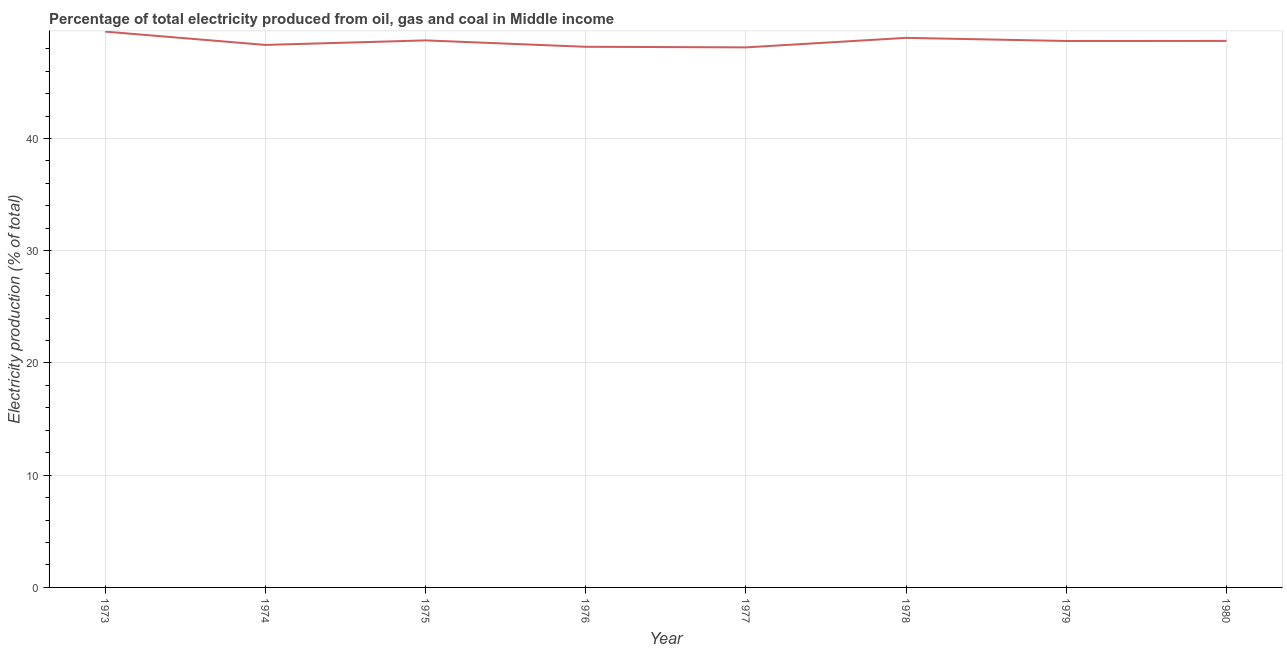What is the electricity production in 1979?
Ensure brevity in your answer.  48.7. Across all years, what is the maximum electricity production?
Your answer should be compact. 49.53. Across all years, what is the minimum electricity production?
Offer a terse response. 48.12. In which year was the electricity production minimum?
Provide a succinct answer. 1977. What is the sum of the electricity production?
Provide a succinct answer. 389.29. What is the difference between the electricity production in 1973 and 1974?
Provide a succinct answer. 1.19. What is the average electricity production per year?
Your answer should be very brief. 48.66. What is the median electricity production?
Provide a succinct answer. 48.7. Do a majority of the years between 1974 and 1976 (inclusive) have electricity production greater than 24 %?
Your answer should be very brief. Yes. What is the ratio of the electricity production in 1973 to that in 1975?
Offer a very short reply. 1.02. Is the electricity production in 1973 less than that in 1978?
Ensure brevity in your answer.  No. Is the difference between the electricity production in 1977 and 1978 greater than the difference between any two years?
Keep it short and to the point. No. What is the difference between the highest and the second highest electricity production?
Your answer should be very brief. 0.56. What is the difference between the highest and the lowest electricity production?
Your response must be concise. 1.41. In how many years, is the electricity production greater than the average electricity production taken over all years?
Keep it short and to the point. 5. Does the electricity production monotonically increase over the years?
Provide a succinct answer. No. What is the difference between two consecutive major ticks on the Y-axis?
Your answer should be compact. 10. Are the values on the major ticks of Y-axis written in scientific E-notation?
Make the answer very short. No. What is the title of the graph?
Your answer should be very brief. Percentage of total electricity produced from oil, gas and coal in Middle income. What is the label or title of the X-axis?
Your answer should be very brief. Year. What is the label or title of the Y-axis?
Offer a very short reply. Electricity production (% of total). What is the Electricity production (% of total) of 1973?
Make the answer very short. 49.53. What is the Electricity production (% of total) of 1974?
Give a very brief answer. 48.34. What is the Electricity production (% of total) in 1975?
Your answer should be compact. 48.75. What is the Electricity production (% of total) in 1976?
Offer a terse response. 48.18. What is the Electricity production (% of total) in 1977?
Your answer should be compact. 48.12. What is the Electricity production (% of total) of 1978?
Keep it short and to the point. 48.97. What is the Electricity production (% of total) of 1979?
Ensure brevity in your answer.  48.7. What is the Electricity production (% of total) in 1980?
Provide a short and direct response. 48.7. What is the difference between the Electricity production (% of total) in 1973 and 1974?
Offer a terse response. 1.19. What is the difference between the Electricity production (% of total) in 1973 and 1975?
Your answer should be compact. 0.78. What is the difference between the Electricity production (% of total) in 1973 and 1976?
Provide a short and direct response. 1.35. What is the difference between the Electricity production (% of total) in 1973 and 1977?
Your response must be concise. 1.41. What is the difference between the Electricity production (% of total) in 1973 and 1978?
Your response must be concise. 0.56. What is the difference between the Electricity production (% of total) in 1973 and 1979?
Provide a short and direct response. 0.83. What is the difference between the Electricity production (% of total) in 1973 and 1980?
Your response must be concise. 0.83. What is the difference between the Electricity production (% of total) in 1974 and 1975?
Your answer should be very brief. -0.4. What is the difference between the Electricity production (% of total) in 1974 and 1976?
Give a very brief answer. 0.17. What is the difference between the Electricity production (% of total) in 1974 and 1977?
Offer a terse response. 0.22. What is the difference between the Electricity production (% of total) in 1974 and 1978?
Provide a succinct answer. -0.63. What is the difference between the Electricity production (% of total) in 1974 and 1979?
Keep it short and to the point. -0.35. What is the difference between the Electricity production (% of total) in 1974 and 1980?
Provide a succinct answer. -0.36. What is the difference between the Electricity production (% of total) in 1975 and 1976?
Your answer should be very brief. 0.57. What is the difference between the Electricity production (% of total) in 1975 and 1977?
Keep it short and to the point. 0.62. What is the difference between the Electricity production (% of total) in 1975 and 1978?
Keep it short and to the point. -0.23. What is the difference between the Electricity production (% of total) in 1975 and 1979?
Provide a succinct answer. 0.05. What is the difference between the Electricity production (% of total) in 1975 and 1980?
Offer a terse response. 0.05. What is the difference between the Electricity production (% of total) in 1976 and 1977?
Your answer should be compact. 0.05. What is the difference between the Electricity production (% of total) in 1976 and 1978?
Offer a terse response. -0.8. What is the difference between the Electricity production (% of total) in 1976 and 1979?
Provide a succinct answer. -0.52. What is the difference between the Electricity production (% of total) in 1976 and 1980?
Your answer should be compact. -0.52. What is the difference between the Electricity production (% of total) in 1977 and 1978?
Offer a very short reply. -0.85. What is the difference between the Electricity production (% of total) in 1977 and 1979?
Give a very brief answer. -0.57. What is the difference between the Electricity production (% of total) in 1977 and 1980?
Offer a terse response. -0.58. What is the difference between the Electricity production (% of total) in 1978 and 1979?
Offer a terse response. 0.28. What is the difference between the Electricity production (% of total) in 1978 and 1980?
Your answer should be very brief. 0.27. What is the difference between the Electricity production (% of total) in 1979 and 1980?
Keep it short and to the point. -0.01. What is the ratio of the Electricity production (% of total) in 1973 to that in 1974?
Offer a very short reply. 1.02. What is the ratio of the Electricity production (% of total) in 1973 to that in 1976?
Your answer should be compact. 1.03. What is the ratio of the Electricity production (% of total) in 1973 to that in 1977?
Offer a very short reply. 1.03. What is the ratio of the Electricity production (% of total) in 1973 to that in 1978?
Your answer should be compact. 1.01. What is the ratio of the Electricity production (% of total) in 1973 to that in 1979?
Give a very brief answer. 1.02. What is the ratio of the Electricity production (% of total) in 1974 to that in 1975?
Make the answer very short. 0.99. What is the ratio of the Electricity production (% of total) in 1974 to that in 1977?
Your answer should be compact. 1. What is the ratio of the Electricity production (% of total) in 1974 to that in 1980?
Offer a very short reply. 0.99. What is the ratio of the Electricity production (% of total) in 1976 to that in 1977?
Ensure brevity in your answer.  1. What is the ratio of the Electricity production (% of total) in 1976 to that in 1979?
Keep it short and to the point. 0.99. What is the ratio of the Electricity production (% of total) in 1977 to that in 1978?
Your response must be concise. 0.98. What is the ratio of the Electricity production (% of total) in 1977 to that in 1979?
Provide a succinct answer. 0.99. What is the ratio of the Electricity production (% of total) in 1977 to that in 1980?
Offer a terse response. 0.99. What is the ratio of the Electricity production (% of total) in 1978 to that in 1979?
Ensure brevity in your answer.  1.01. What is the ratio of the Electricity production (% of total) in 1978 to that in 1980?
Offer a very short reply. 1.01. 